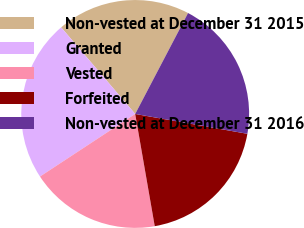<chart> <loc_0><loc_0><loc_500><loc_500><pie_chart><fcel>Non-vested at December 31 2015<fcel>Granted<fcel>Vested<fcel>Forfeited<fcel>Non-vested at December 31 2016<nl><fcel>18.94%<fcel>23.0%<fcel>18.49%<fcel>19.47%<fcel>20.11%<nl></chart> 